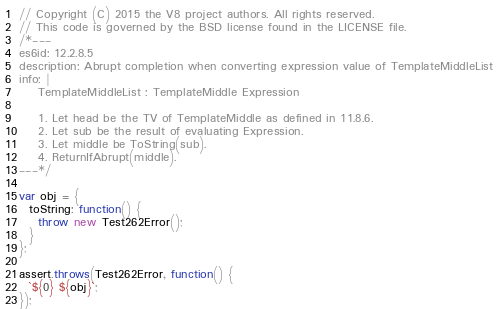<code> <loc_0><loc_0><loc_500><loc_500><_JavaScript_>// Copyright (C) 2015 the V8 project authors. All rights reserved.
// This code is governed by the BSD license found in the LICENSE file.
/*---
es6id: 12.2.8.5
description: Abrupt completion when converting expression value of TemplateMiddleList
info: |
    TemplateMiddleList : TemplateMiddle Expression

    1. Let head be the TV of TemplateMiddle as defined in 11.8.6.
    2. Let sub be the result of evaluating Expression.
    3. Let middle be ToString(sub).
    4. ReturnIfAbrupt(middle).
---*/

var obj = {
  toString: function() {
    throw new Test262Error();
  }
};

assert.throws(Test262Error, function() {
  `${0} ${obj}`;
});
</code> 